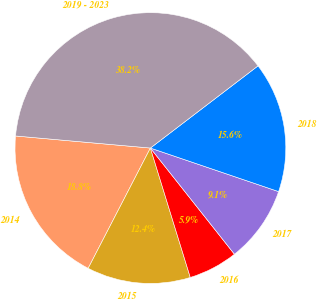<chart> <loc_0><loc_0><loc_500><loc_500><pie_chart><fcel>2014<fcel>2015<fcel>2016<fcel>2017<fcel>2018<fcel>2019 - 2023<nl><fcel>18.82%<fcel>12.36%<fcel>5.9%<fcel>9.13%<fcel>15.59%<fcel>38.2%<nl></chart> 